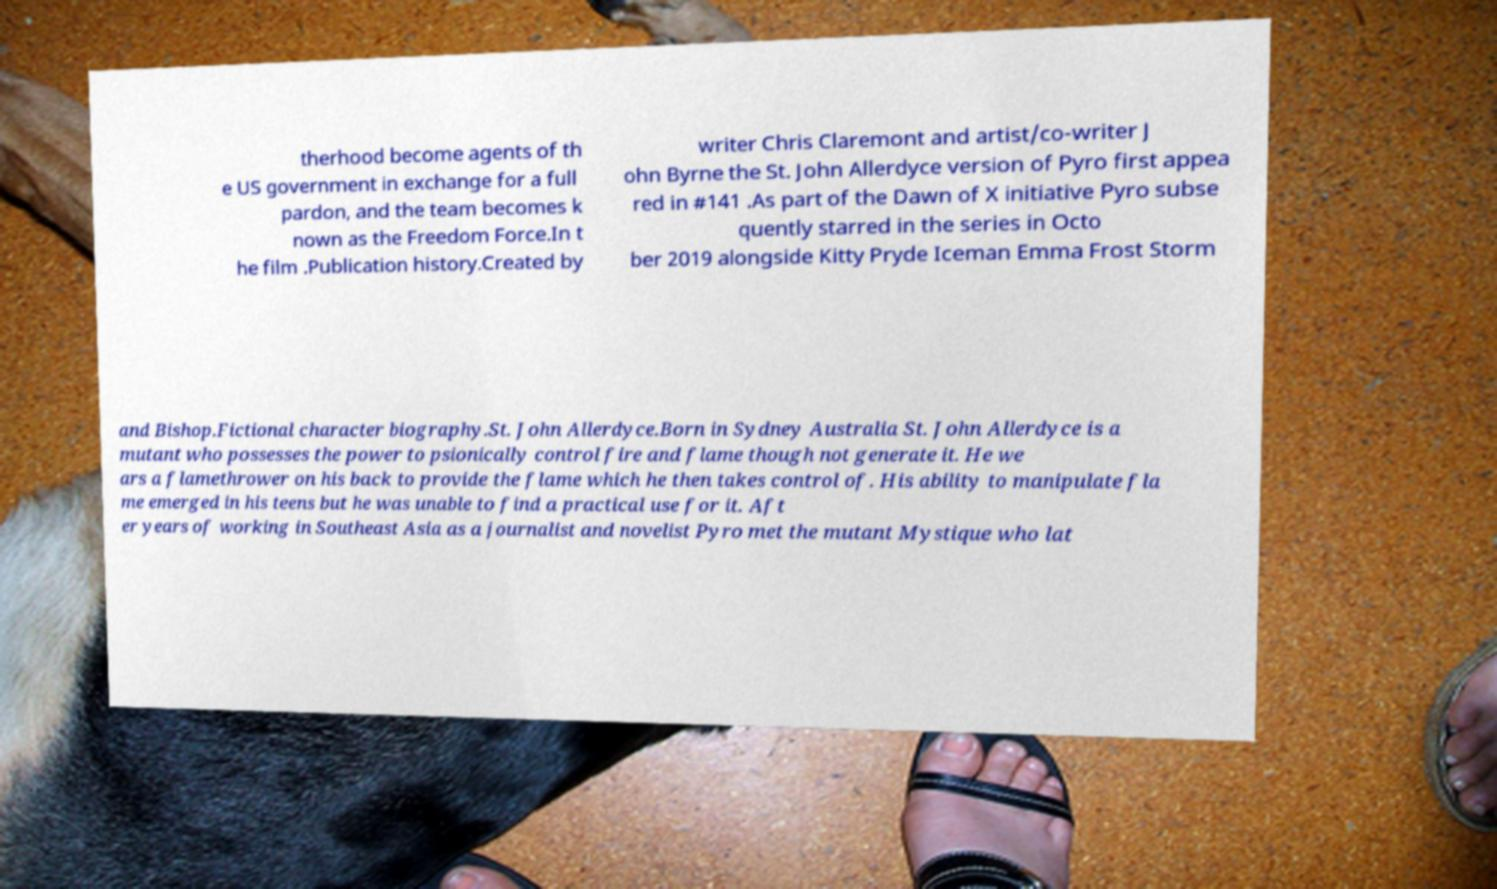Could you assist in decoding the text presented in this image and type it out clearly? therhood become agents of th e US government in exchange for a full pardon, and the team becomes k nown as the Freedom Force.In t he film .Publication history.Created by writer Chris Claremont and artist/co-writer J ohn Byrne the St. John Allerdyce version of Pyro first appea red in #141 .As part of the Dawn of X initiative Pyro subse quently starred in the series in Octo ber 2019 alongside Kitty Pryde Iceman Emma Frost Storm and Bishop.Fictional character biography.St. John Allerdyce.Born in Sydney Australia St. John Allerdyce is a mutant who possesses the power to psionically control fire and flame though not generate it. He we ars a flamethrower on his back to provide the flame which he then takes control of. His ability to manipulate fla me emerged in his teens but he was unable to find a practical use for it. Aft er years of working in Southeast Asia as a journalist and novelist Pyro met the mutant Mystique who lat 